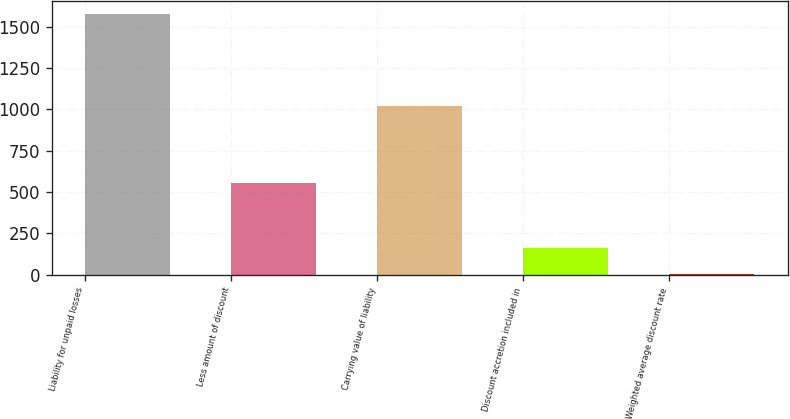Convert chart. <chart><loc_0><loc_0><loc_500><loc_500><bar_chart><fcel>Liability for unpaid losses<fcel>Less amount of discount<fcel>Carrying value of liability<fcel>Discount accretion included in<fcel>Weighted average discount rate<nl><fcel>1577<fcel>556<fcel>1021<fcel>160.85<fcel>3.5<nl></chart> 